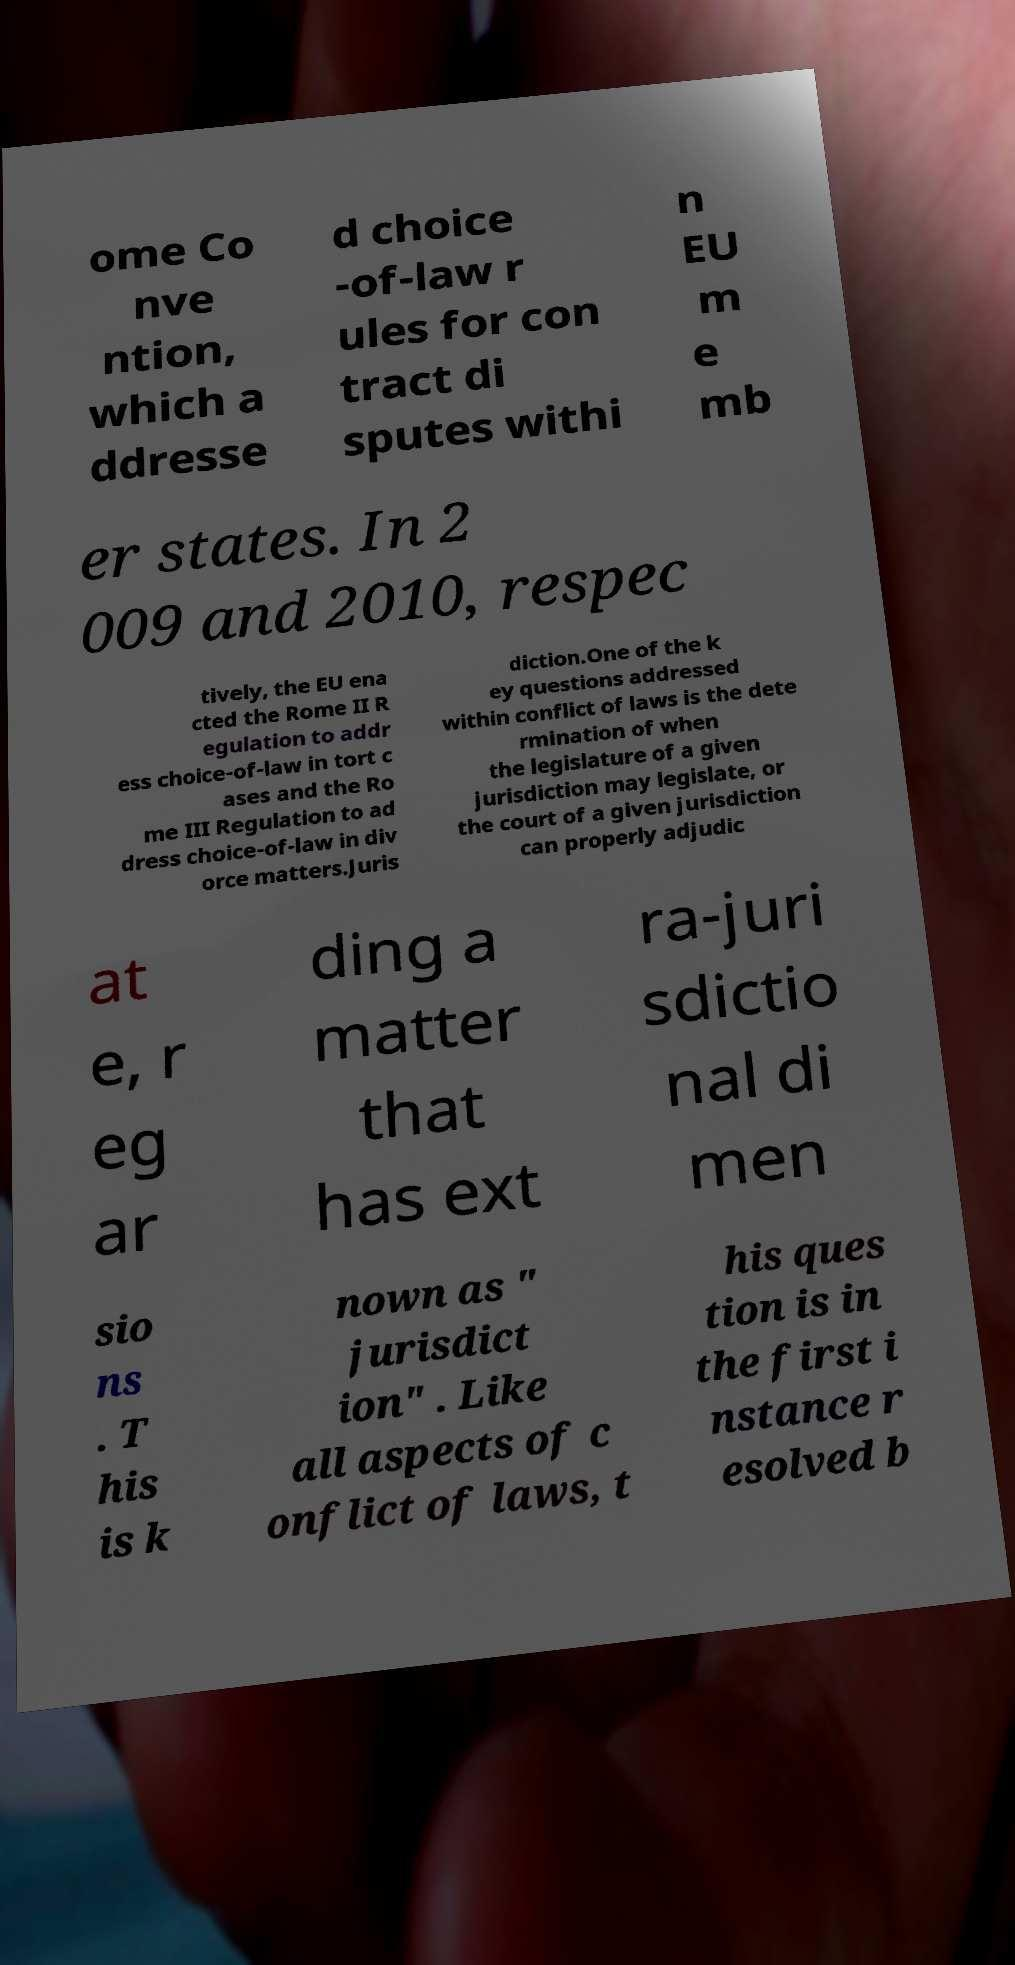There's text embedded in this image that I need extracted. Can you transcribe it verbatim? ome Co nve ntion, which a ddresse d choice -of-law r ules for con tract di sputes withi n EU m e mb er states. In 2 009 and 2010, respec tively, the EU ena cted the Rome II R egulation to addr ess choice-of-law in tort c ases and the Ro me III Regulation to ad dress choice-of-law in div orce matters.Juris diction.One of the k ey questions addressed within conflict of laws is the dete rmination of when the legislature of a given jurisdiction may legislate, or the court of a given jurisdiction can properly adjudic at e, r eg ar ding a matter that has ext ra-juri sdictio nal di men sio ns . T his is k nown as " jurisdict ion" . Like all aspects of c onflict of laws, t his ques tion is in the first i nstance r esolved b 